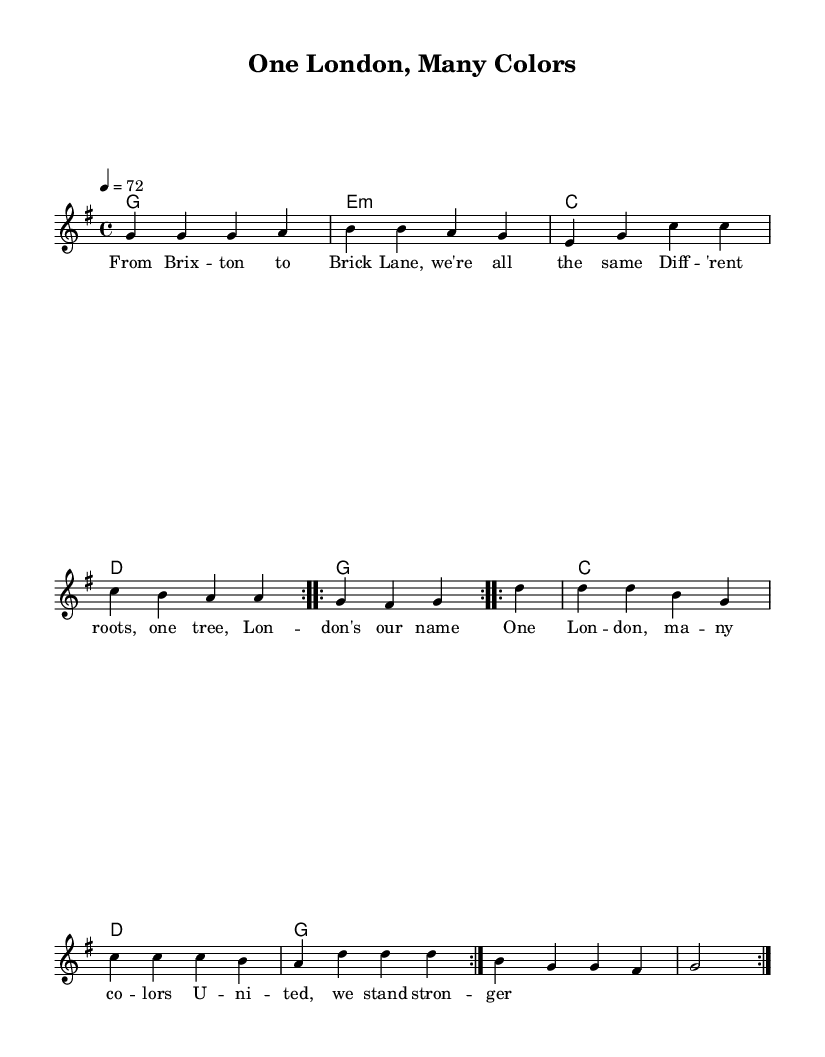What is the key signature of this music? The key signature is G major, which has one sharp (F#).
Answer: G major What is the time signature of the piece? The time signature is 4/4, which means there are four beats per measure.
Answer: 4/4 What is the tempo indicated in the score? The tempo is marked as 4 equals 72, indicating a moderate speed of 72 beats per minute.
Answer: 72 How many times is the melody repeated in the piece? The melody is repeated four times: twice for the first section and twice for the second section.
Answer: Four times What are the first two words of the lyrics? The first two words of the lyrics are "From Brix," which start the thematic celebration of London's diversity.
Answer: From Brix Which section of the song contains the phrase "One London, many colors"? The phrase "One London, many colors" appears in the chorus section of the song.
Answer: Chorus What genre does this piece belong to? This piece belongs to the reggae genre, characterized by its slow tempo and emphasis on offbeats, as well as its themes of unity and multiculturalism.
Answer: Reggae 